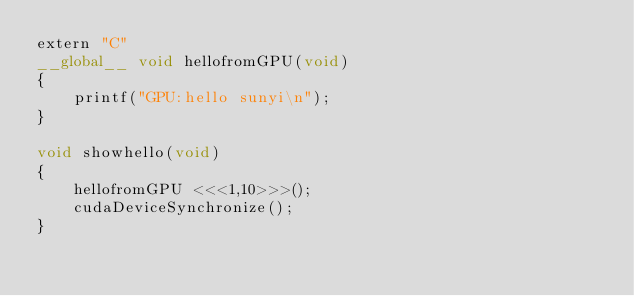<code> <loc_0><loc_0><loc_500><loc_500><_Cuda_>extern "C"
__global__ void hellofromGPU(void)
{
    printf("GPU:hello sunyi\n");
}

void showhello(void)
{
    hellofromGPU <<<1,10>>>();
    cudaDeviceSynchronize();
}
</code> 